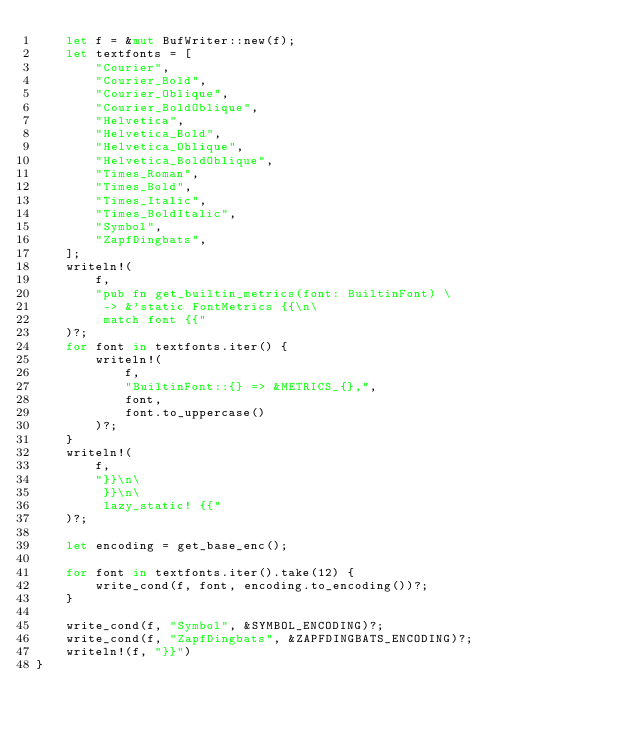<code> <loc_0><loc_0><loc_500><loc_500><_Rust_>    let f = &mut BufWriter::new(f);
    let textfonts = [
        "Courier",
        "Courier_Bold",
        "Courier_Oblique",
        "Courier_BoldOblique",
        "Helvetica",
        "Helvetica_Bold",
        "Helvetica_Oblique",
        "Helvetica_BoldOblique",
        "Times_Roman",
        "Times_Bold",
        "Times_Italic",
        "Times_BoldItalic",
        "Symbol",
        "ZapfDingbats",
    ];
    writeln!(
        f,
        "pub fn get_builtin_metrics(font: BuiltinFont) \
         -> &'static FontMetrics {{\n\
         match font {{"
    )?;
    for font in textfonts.iter() {
        writeln!(
            f,
            "BuiltinFont::{} => &METRICS_{},",
            font,
            font.to_uppercase()
        )?;
    }
    writeln!(
        f,
        "}}\n\
         }}\n\
         lazy_static! {{"
    )?;

    let encoding = get_base_enc();

    for font in textfonts.iter().take(12) {
        write_cond(f, font, encoding.to_encoding())?;
    }

    write_cond(f, "Symbol", &SYMBOL_ENCODING)?;
    write_cond(f, "ZapfDingbats", &ZAPFDINGBATS_ENCODING)?;
    writeln!(f, "}}")
}
</code> 